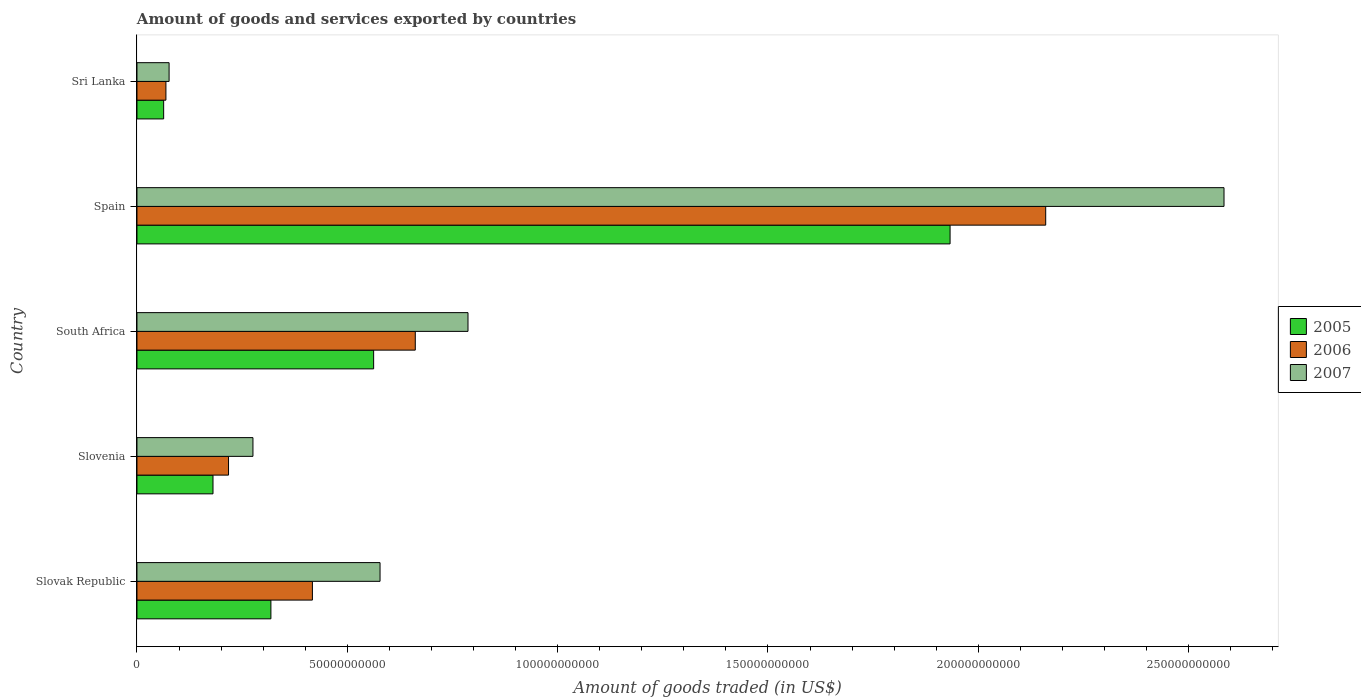How many different coloured bars are there?
Keep it short and to the point. 3. Are the number of bars per tick equal to the number of legend labels?
Provide a short and direct response. Yes. Are the number of bars on each tick of the Y-axis equal?
Keep it short and to the point. Yes. How many bars are there on the 5th tick from the bottom?
Offer a very short reply. 3. What is the label of the 2nd group of bars from the top?
Provide a short and direct response. Spain. In how many cases, is the number of bars for a given country not equal to the number of legend labels?
Ensure brevity in your answer.  0. What is the total amount of goods and services exported in 2006 in Slovak Republic?
Offer a terse response. 4.17e+1. Across all countries, what is the maximum total amount of goods and services exported in 2005?
Your answer should be very brief. 1.93e+11. Across all countries, what is the minimum total amount of goods and services exported in 2005?
Provide a short and direct response. 6.35e+09. In which country was the total amount of goods and services exported in 2005 minimum?
Ensure brevity in your answer.  Sri Lanka. What is the total total amount of goods and services exported in 2007 in the graph?
Offer a very short reply. 4.30e+11. What is the difference between the total amount of goods and services exported in 2007 in Slovak Republic and that in South Africa?
Keep it short and to the point. -2.09e+1. What is the difference between the total amount of goods and services exported in 2005 in Spain and the total amount of goods and services exported in 2007 in Slovenia?
Ensure brevity in your answer.  1.66e+11. What is the average total amount of goods and services exported in 2006 per country?
Make the answer very short. 7.05e+1. What is the difference between the total amount of goods and services exported in 2005 and total amount of goods and services exported in 2007 in Spain?
Give a very brief answer. -6.51e+1. In how many countries, is the total amount of goods and services exported in 2006 greater than 60000000000 US$?
Ensure brevity in your answer.  2. What is the ratio of the total amount of goods and services exported in 2005 in Slovenia to that in Spain?
Your answer should be very brief. 0.09. Is the total amount of goods and services exported in 2005 in Slovak Republic less than that in Slovenia?
Offer a very short reply. No. What is the difference between the highest and the second highest total amount of goods and services exported in 2007?
Offer a very short reply. 1.80e+11. What is the difference between the highest and the lowest total amount of goods and services exported in 2007?
Make the answer very short. 2.51e+11. In how many countries, is the total amount of goods and services exported in 2006 greater than the average total amount of goods and services exported in 2006 taken over all countries?
Offer a very short reply. 1. Is the sum of the total amount of goods and services exported in 2006 in Slovenia and Spain greater than the maximum total amount of goods and services exported in 2007 across all countries?
Provide a succinct answer. No. What does the 1st bar from the top in South Africa represents?
Ensure brevity in your answer.  2007. How many countries are there in the graph?
Offer a very short reply. 5. What is the difference between two consecutive major ticks on the X-axis?
Provide a succinct answer. 5.00e+1. Are the values on the major ticks of X-axis written in scientific E-notation?
Ensure brevity in your answer.  No. Does the graph contain any zero values?
Make the answer very short. No. What is the title of the graph?
Provide a short and direct response. Amount of goods and services exported by countries. What is the label or title of the X-axis?
Offer a terse response. Amount of goods traded (in US$). What is the label or title of the Y-axis?
Make the answer very short. Country. What is the Amount of goods traded (in US$) in 2005 in Slovak Republic?
Offer a terse response. 3.18e+1. What is the Amount of goods traded (in US$) of 2006 in Slovak Republic?
Offer a very short reply. 4.17e+1. What is the Amount of goods traded (in US$) in 2007 in Slovak Republic?
Provide a short and direct response. 5.78e+1. What is the Amount of goods traded (in US$) in 2005 in Slovenia?
Keep it short and to the point. 1.81e+1. What is the Amount of goods traded (in US$) of 2006 in Slovenia?
Make the answer very short. 2.18e+1. What is the Amount of goods traded (in US$) of 2007 in Slovenia?
Provide a succinct answer. 2.76e+1. What is the Amount of goods traded (in US$) of 2005 in South Africa?
Make the answer very short. 5.63e+1. What is the Amount of goods traded (in US$) in 2006 in South Africa?
Your answer should be very brief. 6.62e+1. What is the Amount of goods traded (in US$) of 2007 in South Africa?
Provide a succinct answer. 7.87e+1. What is the Amount of goods traded (in US$) of 2005 in Spain?
Your answer should be compact. 1.93e+11. What is the Amount of goods traded (in US$) of 2006 in Spain?
Give a very brief answer. 2.16e+11. What is the Amount of goods traded (in US$) in 2007 in Spain?
Offer a terse response. 2.58e+11. What is the Amount of goods traded (in US$) in 2005 in Sri Lanka?
Offer a very short reply. 6.35e+09. What is the Amount of goods traded (in US$) in 2006 in Sri Lanka?
Offer a very short reply. 6.88e+09. What is the Amount of goods traded (in US$) in 2007 in Sri Lanka?
Ensure brevity in your answer.  7.64e+09. Across all countries, what is the maximum Amount of goods traded (in US$) of 2005?
Make the answer very short. 1.93e+11. Across all countries, what is the maximum Amount of goods traded (in US$) in 2006?
Your answer should be very brief. 2.16e+11. Across all countries, what is the maximum Amount of goods traded (in US$) in 2007?
Your answer should be compact. 2.58e+11. Across all countries, what is the minimum Amount of goods traded (in US$) in 2005?
Your answer should be compact. 6.35e+09. Across all countries, what is the minimum Amount of goods traded (in US$) of 2006?
Your response must be concise. 6.88e+09. Across all countries, what is the minimum Amount of goods traded (in US$) of 2007?
Your response must be concise. 7.64e+09. What is the total Amount of goods traded (in US$) of 2005 in the graph?
Offer a very short reply. 3.06e+11. What is the total Amount of goods traded (in US$) of 2006 in the graph?
Your answer should be very brief. 3.53e+11. What is the total Amount of goods traded (in US$) of 2007 in the graph?
Your answer should be compact. 4.30e+11. What is the difference between the Amount of goods traded (in US$) in 2005 in Slovak Republic and that in Slovenia?
Offer a terse response. 1.38e+1. What is the difference between the Amount of goods traded (in US$) in 2006 in Slovak Republic and that in Slovenia?
Keep it short and to the point. 1.99e+1. What is the difference between the Amount of goods traded (in US$) of 2007 in Slovak Republic and that in Slovenia?
Your response must be concise. 3.02e+1. What is the difference between the Amount of goods traded (in US$) in 2005 in Slovak Republic and that in South Africa?
Your answer should be very brief. -2.44e+1. What is the difference between the Amount of goods traded (in US$) in 2006 in Slovak Republic and that in South Africa?
Offer a very short reply. -2.45e+1. What is the difference between the Amount of goods traded (in US$) in 2007 in Slovak Republic and that in South Africa?
Keep it short and to the point. -2.09e+1. What is the difference between the Amount of goods traded (in US$) of 2005 in Slovak Republic and that in Spain?
Ensure brevity in your answer.  -1.61e+11. What is the difference between the Amount of goods traded (in US$) of 2006 in Slovak Republic and that in Spain?
Give a very brief answer. -1.74e+11. What is the difference between the Amount of goods traded (in US$) of 2007 in Slovak Republic and that in Spain?
Keep it short and to the point. -2.01e+11. What is the difference between the Amount of goods traded (in US$) of 2005 in Slovak Republic and that in Sri Lanka?
Make the answer very short. 2.55e+1. What is the difference between the Amount of goods traded (in US$) of 2006 in Slovak Republic and that in Sri Lanka?
Give a very brief answer. 3.48e+1. What is the difference between the Amount of goods traded (in US$) in 2007 in Slovak Republic and that in Sri Lanka?
Provide a succinct answer. 5.01e+1. What is the difference between the Amount of goods traded (in US$) of 2005 in Slovenia and that in South Africa?
Make the answer very short. -3.82e+1. What is the difference between the Amount of goods traded (in US$) in 2006 in Slovenia and that in South Africa?
Provide a succinct answer. -4.44e+1. What is the difference between the Amount of goods traded (in US$) of 2007 in Slovenia and that in South Africa?
Give a very brief answer. -5.11e+1. What is the difference between the Amount of goods traded (in US$) of 2005 in Slovenia and that in Spain?
Your answer should be very brief. -1.75e+11. What is the difference between the Amount of goods traded (in US$) in 2006 in Slovenia and that in Spain?
Provide a short and direct response. -1.94e+11. What is the difference between the Amount of goods traded (in US$) of 2007 in Slovenia and that in Spain?
Offer a terse response. -2.31e+11. What is the difference between the Amount of goods traded (in US$) in 2005 in Slovenia and that in Sri Lanka?
Offer a terse response. 1.17e+1. What is the difference between the Amount of goods traded (in US$) of 2006 in Slovenia and that in Sri Lanka?
Give a very brief answer. 1.49e+1. What is the difference between the Amount of goods traded (in US$) in 2007 in Slovenia and that in Sri Lanka?
Make the answer very short. 1.99e+1. What is the difference between the Amount of goods traded (in US$) in 2005 in South Africa and that in Spain?
Offer a terse response. -1.37e+11. What is the difference between the Amount of goods traded (in US$) in 2006 in South Africa and that in Spain?
Offer a very short reply. -1.50e+11. What is the difference between the Amount of goods traded (in US$) of 2007 in South Africa and that in Spain?
Offer a terse response. -1.80e+11. What is the difference between the Amount of goods traded (in US$) of 2005 in South Africa and that in Sri Lanka?
Keep it short and to the point. 4.99e+1. What is the difference between the Amount of goods traded (in US$) in 2006 in South Africa and that in Sri Lanka?
Your answer should be compact. 5.93e+1. What is the difference between the Amount of goods traded (in US$) in 2007 in South Africa and that in Sri Lanka?
Make the answer very short. 7.11e+1. What is the difference between the Amount of goods traded (in US$) of 2005 in Spain and that in Sri Lanka?
Provide a succinct answer. 1.87e+11. What is the difference between the Amount of goods traded (in US$) of 2006 in Spain and that in Sri Lanka?
Offer a terse response. 2.09e+11. What is the difference between the Amount of goods traded (in US$) in 2007 in Spain and that in Sri Lanka?
Keep it short and to the point. 2.51e+11. What is the difference between the Amount of goods traded (in US$) in 2005 in Slovak Republic and the Amount of goods traded (in US$) in 2006 in Slovenia?
Your answer should be compact. 1.01e+1. What is the difference between the Amount of goods traded (in US$) in 2005 in Slovak Republic and the Amount of goods traded (in US$) in 2007 in Slovenia?
Give a very brief answer. 4.27e+09. What is the difference between the Amount of goods traded (in US$) in 2006 in Slovak Republic and the Amount of goods traded (in US$) in 2007 in Slovenia?
Keep it short and to the point. 1.41e+1. What is the difference between the Amount of goods traded (in US$) in 2005 in Slovak Republic and the Amount of goods traded (in US$) in 2006 in South Africa?
Ensure brevity in your answer.  -3.43e+1. What is the difference between the Amount of goods traded (in US$) in 2005 in Slovak Republic and the Amount of goods traded (in US$) in 2007 in South Africa?
Your response must be concise. -4.69e+1. What is the difference between the Amount of goods traded (in US$) in 2006 in Slovak Republic and the Amount of goods traded (in US$) in 2007 in South Africa?
Offer a terse response. -3.70e+1. What is the difference between the Amount of goods traded (in US$) of 2005 in Slovak Republic and the Amount of goods traded (in US$) of 2006 in Spain?
Give a very brief answer. -1.84e+11. What is the difference between the Amount of goods traded (in US$) in 2005 in Slovak Republic and the Amount of goods traded (in US$) in 2007 in Spain?
Make the answer very short. -2.27e+11. What is the difference between the Amount of goods traded (in US$) in 2006 in Slovak Republic and the Amount of goods traded (in US$) in 2007 in Spain?
Ensure brevity in your answer.  -2.17e+11. What is the difference between the Amount of goods traded (in US$) of 2005 in Slovak Republic and the Amount of goods traded (in US$) of 2006 in Sri Lanka?
Your answer should be very brief. 2.50e+1. What is the difference between the Amount of goods traded (in US$) in 2005 in Slovak Republic and the Amount of goods traded (in US$) in 2007 in Sri Lanka?
Your answer should be very brief. 2.42e+1. What is the difference between the Amount of goods traded (in US$) in 2006 in Slovak Republic and the Amount of goods traded (in US$) in 2007 in Sri Lanka?
Provide a short and direct response. 3.41e+1. What is the difference between the Amount of goods traded (in US$) of 2005 in Slovenia and the Amount of goods traded (in US$) of 2006 in South Africa?
Your response must be concise. -4.81e+1. What is the difference between the Amount of goods traded (in US$) of 2005 in Slovenia and the Amount of goods traded (in US$) of 2007 in South Africa?
Offer a terse response. -6.06e+1. What is the difference between the Amount of goods traded (in US$) of 2006 in Slovenia and the Amount of goods traded (in US$) of 2007 in South Africa?
Your response must be concise. -5.69e+1. What is the difference between the Amount of goods traded (in US$) in 2005 in Slovenia and the Amount of goods traded (in US$) in 2006 in Spain?
Keep it short and to the point. -1.98e+11. What is the difference between the Amount of goods traded (in US$) of 2005 in Slovenia and the Amount of goods traded (in US$) of 2007 in Spain?
Your answer should be very brief. -2.40e+11. What is the difference between the Amount of goods traded (in US$) of 2006 in Slovenia and the Amount of goods traded (in US$) of 2007 in Spain?
Your answer should be compact. -2.37e+11. What is the difference between the Amount of goods traded (in US$) of 2005 in Slovenia and the Amount of goods traded (in US$) of 2006 in Sri Lanka?
Make the answer very short. 1.12e+1. What is the difference between the Amount of goods traded (in US$) in 2005 in Slovenia and the Amount of goods traded (in US$) in 2007 in Sri Lanka?
Keep it short and to the point. 1.04e+1. What is the difference between the Amount of goods traded (in US$) of 2006 in Slovenia and the Amount of goods traded (in US$) of 2007 in Sri Lanka?
Your answer should be compact. 1.41e+1. What is the difference between the Amount of goods traded (in US$) in 2005 in South Africa and the Amount of goods traded (in US$) in 2006 in Spain?
Provide a short and direct response. -1.60e+11. What is the difference between the Amount of goods traded (in US$) in 2005 in South Africa and the Amount of goods traded (in US$) in 2007 in Spain?
Your answer should be very brief. -2.02e+11. What is the difference between the Amount of goods traded (in US$) of 2006 in South Africa and the Amount of goods traded (in US$) of 2007 in Spain?
Your answer should be compact. -1.92e+11. What is the difference between the Amount of goods traded (in US$) in 2005 in South Africa and the Amount of goods traded (in US$) in 2006 in Sri Lanka?
Offer a very short reply. 4.94e+1. What is the difference between the Amount of goods traded (in US$) of 2005 in South Africa and the Amount of goods traded (in US$) of 2007 in Sri Lanka?
Your answer should be very brief. 4.86e+1. What is the difference between the Amount of goods traded (in US$) in 2006 in South Africa and the Amount of goods traded (in US$) in 2007 in Sri Lanka?
Provide a short and direct response. 5.85e+1. What is the difference between the Amount of goods traded (in US$) of 2005 in Spain and the Amount of goods traded (in US$) of 2006 in Sri Lanka?
Your answer should be compact. 1.86e+11. What is the difference between the Amount of goods traded (in US$) in 2005 in Spain and the Amount of goods traded (in US$) in 2007 in Sri Lanka?
Provide a succinct answer. 1.86e+11. What is the difference between the Amount of goods traded (in US$) in 2006 in Spain and the Amount of goods traded (in US$) in 2007 in Sri Lanka?
Make the answer very short. 2.08e+11. What is the average Amount of goods traded (in US$) in 2005 per country?
Provide a short and direct response. 6.12e+1. What is the average Amount of goods traded (in US$) of 2006 per country?
Offer a very short reply. 7.05e+1. What is the average Amount of goods traded (in US$) of 2007 per country?
Provide a succinct answer. 8.60e+1. What is the difference between the Amount of goods traded (in US$) of 2005 and Amount of goods traded (in US$) of 2006 in Slovak Republic?
Offer a terse response. -9.86e+09. What is the difference between the Amount of goods traded (in US$) in 2005 and Amount of goods traded (in US$) in 2007 in Slovak Republic?
Offer a very short reply. -2.59e+1. What is the difference between the Amount of goods traded (in US$) in 2006 and Amount of goods traded (in US$) in 2007 in Slovak Republic?
Offer a very short reply. -1.61e+1. What is the difference between the Amount of goods traded (in US$) in 2005 and Amount of goods traded (in US$) in 2006 in Slovenia?
Provide a short and direct response. -3.69e+09. What is the difference between the Amount of goods traded (in US$) of 2005 and Amount of goods traded (in US$) of 2007 in Slovenia?
Your answer should be very brief. -9.50e+09. What is the difference between the Amount of goods traded (in US$) in 2006 and Amount of goods traded (in US$) in 2007 in Slovenia?
Make the answer very short. -5.81e+09. What is the difference between the Amount of goods traded (in US$) in 2005 and Amount of goods traded (in US$) in 2006 in South Africa?
Your answer should be very brief. -9.90e+09. What is the difference between the Amount of goods traded (in US$) of 2005 and Amount of goods traded (in US$) of 2007 in South Africa?
Provide a short and direct response. -2.24e+1. What is the difference between the Amount of goods traded (in US$) of 2006 and Amount of goods traded (in US$) of 2007 in South Africa?
Provide a short and direct response. -1.25e+1. What is the difference between the Amount of goods traded (in US$) of 2005 and Amount of goods traded (in US$) of 2006 in Spain?
Your response must be concise. -2.27e+1. What is the difference between the Amount of goods traded (in US$) of 2005 and Amount of goods traded (in US$) of 2007 in Spain?
Make the answer very short. -6.51e+1. What is the difference between the Amount of goods traded (in US$) of 2006 and Amount of goods traded (in US$) of 2007 in Spain?
Keep it short and to the point. -4.24e+1. What is the difference between the Amount of goods traded (in US$) of 2005 and Amount of goods traded (in US$) of 2006 in Sri Lanka?
Ensure brevity in your answer.  -5.36e+08. What is the difference between the Amount of goods traded (in US$) of 2005 and Amount of goods traded (in US$) of 2007 in Sri Lanka?
Provide a succinct answer. -1.29e+09. What is the difference between the Amount of goods traded (in US$) in 2006 and Amount of goods traded (in US$) in 2007 in Sri Lanka?
Provide a succinct answer. -7.57e+08. What is the ratio of the Amount of goods traded (in US$) in 2005 in Slovak Republic to that in Slovenia?
Offer a very short reply. 1.76. What is the ratio of the Amount of goods traded (in US$) of 2006 in Slovak Republic to that in Slovenia?
Ensure brevity in your answer.  1.92. What is the ratio of the Amount of goods traded (in US$) in 2007 in Slovak Republic to that in Slovenia?
Provide a succinct answer. 2.1. What is the ratio of the Amount of goods traded (in US$) of 2005 in Slovak Republic to that in South Africa?
Provide a succinct answer. 0.57. What is the ratio of the Amount of goods traded (in US$) of 2006 in Slovak Republic to that in South Africa?
Your answer should be very brief. 0.63. What is the ratio of the Amount of goods traded (in US$) in 2007 in Slovak Republic to that in South Africa?
Your response must be concise. 0.73. What is the ratio of the Amount of goods traded (in US$) in 2005 in Slovak Republic to that in Spain?
Your answer should be very brief. 0.16. What is the ratio of the Amount of goods traded (in US$) in 2006 in Slovak Republic to that in Spain?
Make the answer very short. 0.19. What is the ratio of the Amount of goods traded (in US$) in 2007 in Slovak Republic to that in Spain?
Ensure brevity in your answer.  0.22. What is the ratio of the Amount of goods traded (in US$) in 2005 in Slovak Republic to that in Sri Lanka?
Keep it short and to the point. 5.02. What is the ratio of the Amount of goods traded (in US$) of 2006 in Slovak Republic to that in Sri Lanka?
Give a very brief answer. 6.06. What is the ratio of the Amount of goods traded (in US$) in 2007 in Slovak Republic to that in Sri Lanka?
Your answer should be compact. 7.56. What is the ratio of the Amount of goods traded (in US$) of 2005 in Slovenia to that in South Africa?
Offer a very short reply. 0.32. What is the ratio of the Amount of goods traded (in US$) in 2006 in Slovenia to that in South Africa?
Offer a terse response. 0.33. What is the ratio of the Amount of goods traded (in US$) of 2007 in Slovenia to that in South Africa?
Keep it short and to the point. 0.35. What is the ratio of the Amount of goods traded (in US$) in 2005 in Slovenia to that in Spain?
Ensure brevity in your answer.  0.09. What is the ratio of the Amount of goods traded (in US$) of 2006 in Slovenia to that in Spain?
Offer a very short reply. 0.1. What is the ratio of the Amount of goods traded (in US$) in 2007 in Slovenia to that in Spain?
Provide a short and direct response. 0.11. What is the ratio of the Amount of goods traded (in US$) of 2005 in Slovenia to that in Sri Lanka?
Offer a very short reply. 2.85. What is the ratio of the Amount of goods traded (in US$) of 2006 in Slovenia to that in Sri Lanka?
Your answer should be very brief. 3.16. What is the ratio of the Amount of goods traded (in US$) of 2007 in Slovenia to that in Sri Lanka?
Give a very brief answer. 3.61. What is the ratio of the Amount of goods traded (in US$) in 2005 in South Africa to that in Spain?
Provide a short and direct response. 0.29. What is the ratio of the Amount of goods traded (in US$) in 2006 in South Africa to that in Spain?
Make the answer very short. 0.31. What is the ratio of the Amount of goods traded (in US$) of 2007 in South Africa to that in Spain?
Make the answer very short. 0.3. What is the ratio of the Amount of goods traded (in US$) in 2005 in South Africa to that in Sri Lanka?
Provide a succinct answer. 8.86. What is the ratio of the Amount of goods traded (in US$) of 2006 in South Africa to that in Sri Lanka?
Make the answer very short. 9.61. What is the ratio of the Amount of goods traded (in US$) in 2007 in South Africa to that in Sri Lanka?
Offer a terse response. 10.3. What is the ratio of the Amount of goods traded (in US$) of 2005 in Spain to that in Sri Lanka?
Offer a terse response. 30.45. What is the ratio of the Amount of goods traded (in US$) of 2006 in Spain to that in Sri Lanka?
Your answer should be compact. 31.39. What is the ratio of the Amount of goods traded (in US$) of 2007 in Spain to that in Sri Lanka?
Offer a terse response. 33.82. What is the difference between the highest and the second highest Amount of goods traded (in US$) in 2005?
Your response must be concise. 1.37e+11. What is the difference between the highest and the second highest Amount of goods traded (in US$) of 2006?
Offer a very short reply. 1.50e+11. What is the difference between the highest and the second highest Amount of goods traded (in US$) of 2007?
Offer a terse response. 1.80e+11. What is the difference between the highest and the lowest Amount of goods traded (in US$) in 2005?
Give a very brief answer. 1.87e+11. What is the difference between the highest and the lowest Amount of goods traded (in US$) of 2006?
Your answer should be compact. 2.09e+11. What is the difference between the highest and the lowest Amount of goods traded (in US$) in 2007?
Your answer should be compact. 2.51e+11. 